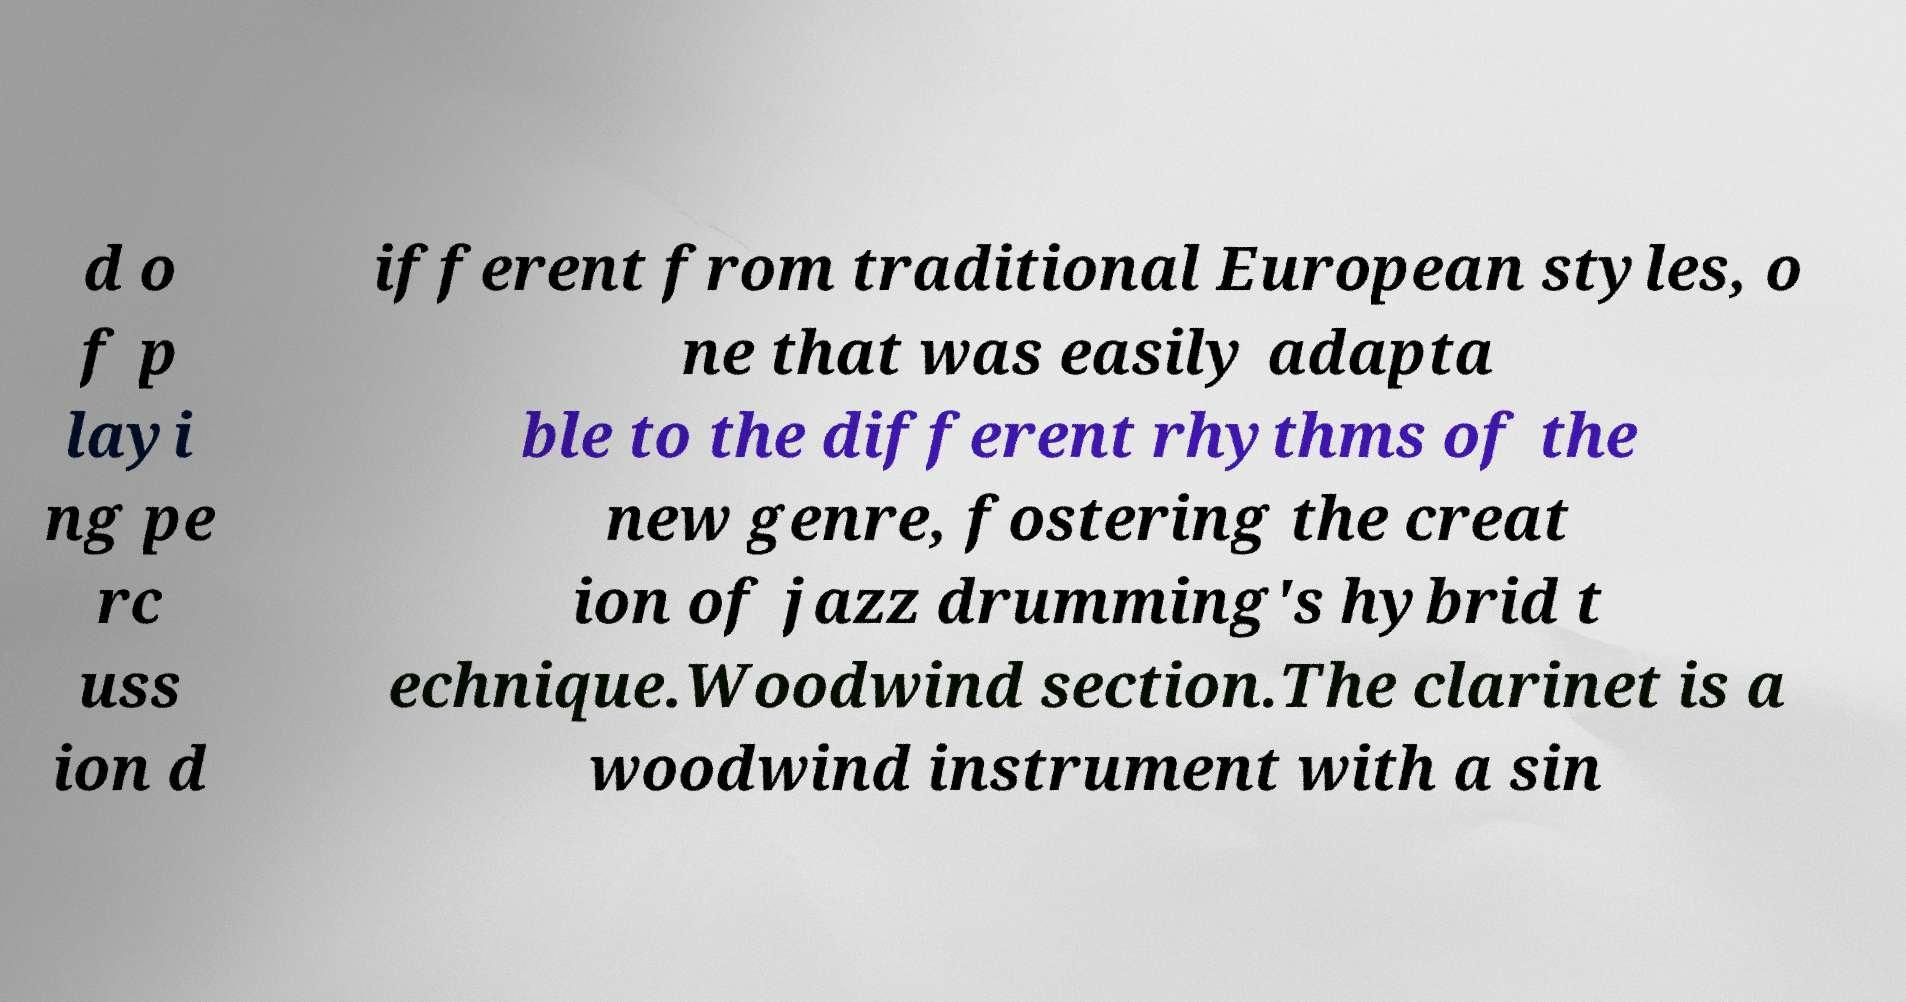For documentation purposes, I need the text within this image transcribed. Could you provide that? d o f p layi ng pe rc uss ion d ifferent from traditional European styles, o ne that was easily adapta ble to the different rhythms of the new genre, fostering the creat ion of jazz drumming's hybrid t echnique.Woodwind section.The clarinet is a woodwind instrument with a sin 